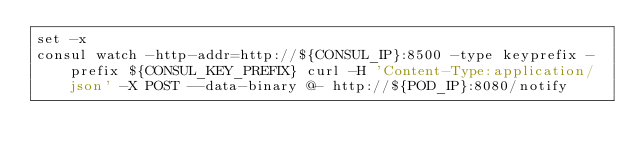Convert code to text. <code><loc_0><loc_0><loc_500><loc_500><_Bash_>set -x
consul watch -http-addr=http://${CONSUL_IP}:8500 -type keyprefix -prefix ${CONSUL_KEY_PREFIX} curl -H 'Content-Type:application/json' -X POST --data-binary @- http://${POD_IP}:8080/notify</code> 